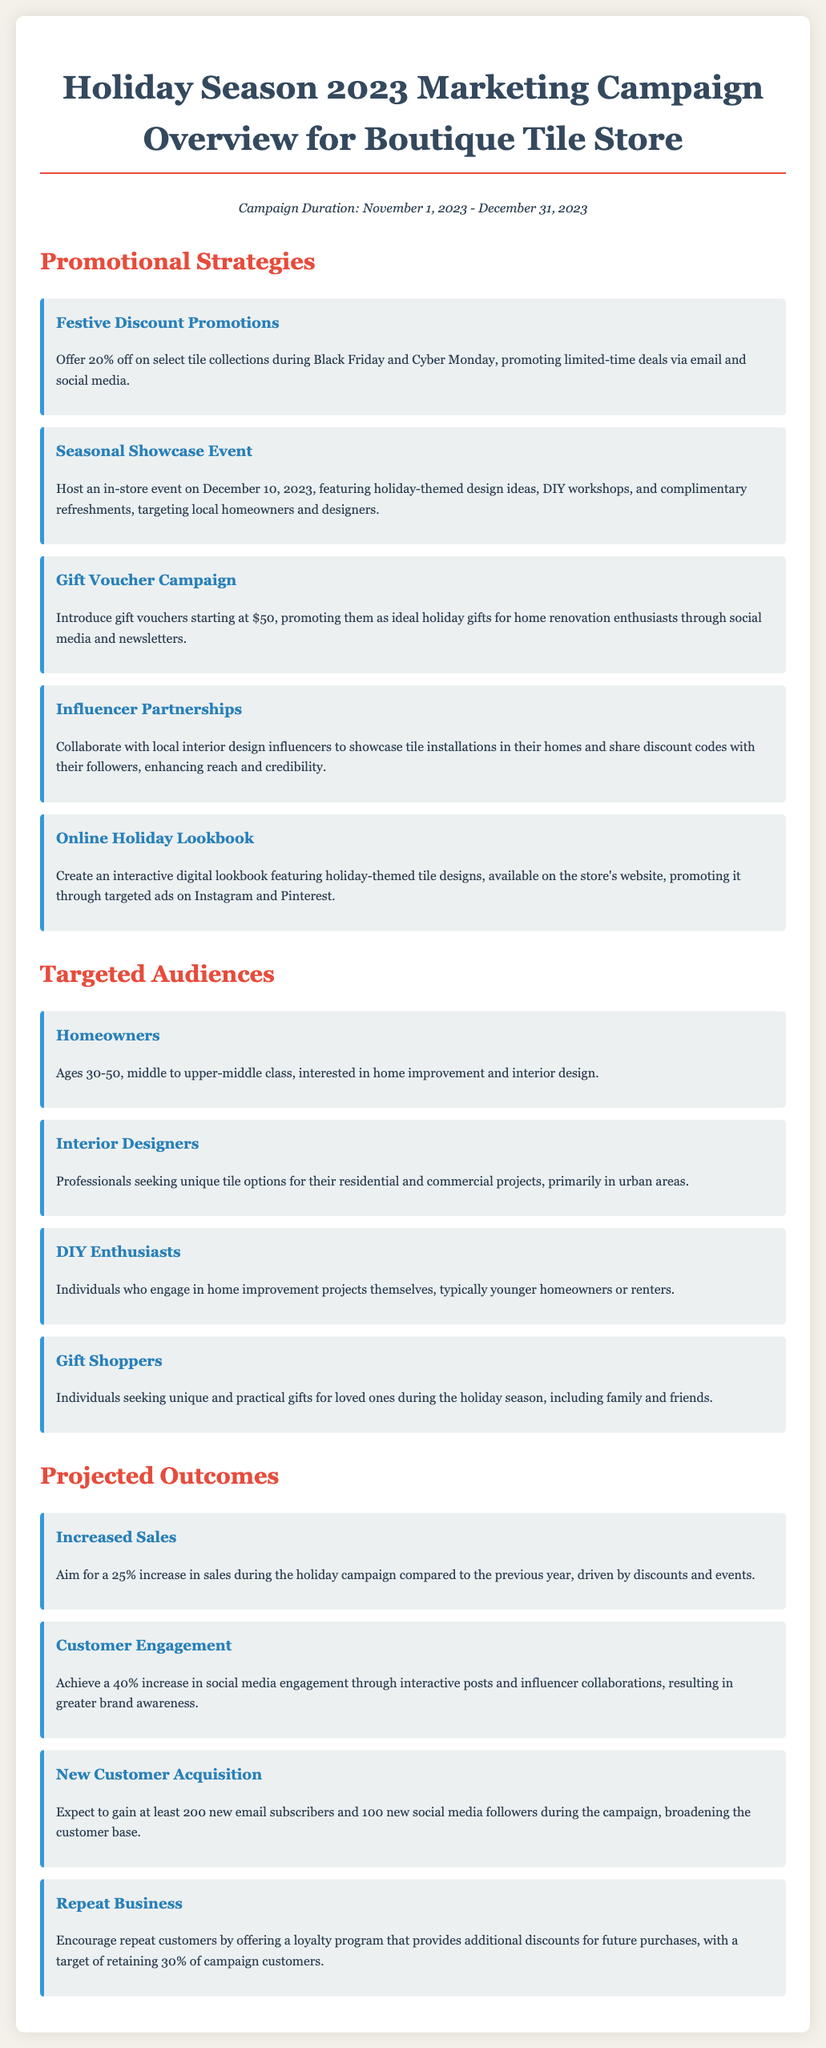What is the campaign duration? The campaign duration is specified in the document as the period for which the marketing initiatives will run.
Answer: November 1, 2023 - December 31, 2023 What percentage discount is offered on select tile collections? The document provides details about the discount percentage that will be applied during promotional events.
Answer: 20% What is the date of the in-store event? The date of the seasonal showcase event is mentioned in the promotional strategies section of the document.
Answer: December 10, 2023 What is the target audience age range for homeowners? The document specifies the age range of the targeted audience segment that includes homeowners.
Answer: Ages 30-50 How many new email subscribers does the campaign expect to gain? The projected outcome section outlines the anticipated increase in email subscribers during the campaign.
Answer: 200 What promotional strategy involves collaborating with local influencers? This question relates to identifying a specific strategy that includes partnerships with external parties for promotional purposes.
Answer: Influencer Partnerships What is the targeted increase in sales during the holiday campaign? The expected increase in sales is highlighted in the projected outcomes, reflecting the objectives of the campaign.
Answer: 25% What is the goal for retaining repeat customers? The desired retention rate for repeat customers after the campaign is stated in the outcomes section.
Answer: 30% 